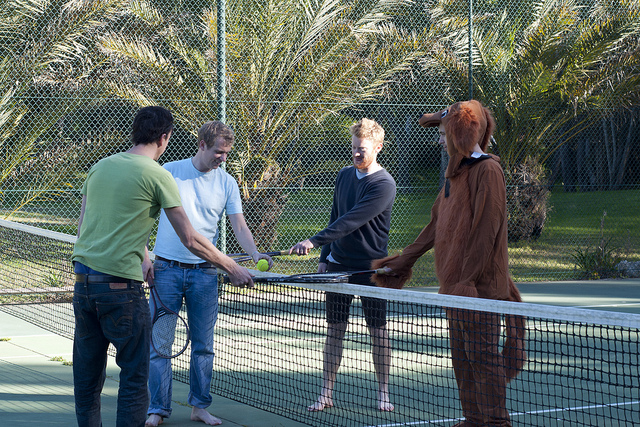Describe the clothing and accessories seen in the image. The individuals in the image are dressed in casual attire suitable for a casual game of tennis. One person wears a green shirt with jeans, another sports a white t-shirt with blue jeans, while the third individual is dressed in a dark long-sleeved shirt and shorts. The most eye-catching outfit is the brown dog costume, with floppy ears and a tail, adding a quirky twist to the group's otherwise simple clothing choice. Some are holding tennis rackets and a tennis ball, emphasizing the sports setting. What would be a good caption for this image? 'A Paws-itively Fun Day on the Court!' 